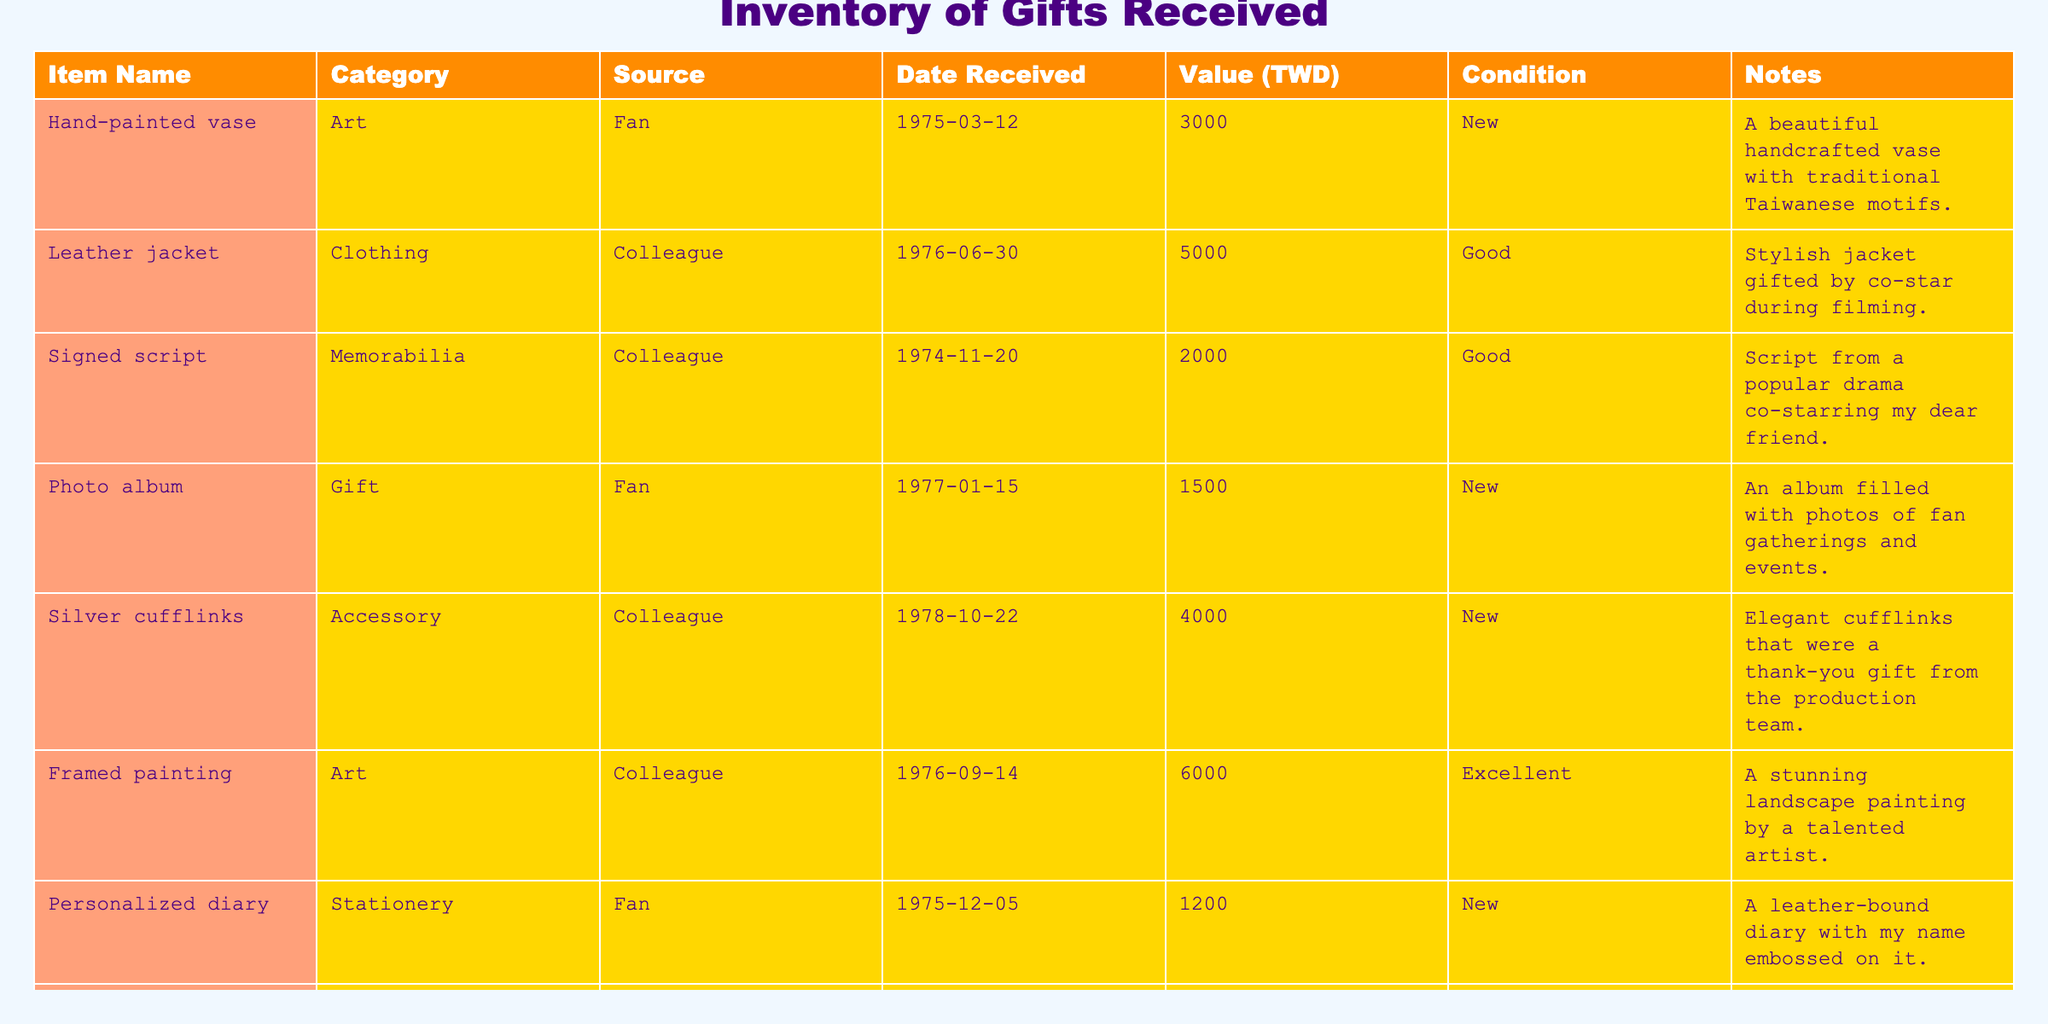What is the value of the hand-painted vase? The table shows that the value of the hand-painted vase is listed as 3000 TWD.
Answer: 3000 TWD How many gifts were received from fans? By reviewing the table, there are three items (hand-painted vase, photo album, ceramic tea set) listed under the source "Fan," indicating a total of three gifts from fans.
Answer: 3 Which item has the highest value? Comparing the values of all items in the table, the framed painting has the highest value at 6000 TWD.
Answer: 6000 TWD Is the personalized diary in new condition? The entry for the personalized diary states that its condition is "New," confirming that the diary is indeed in new condition.
Answer: Yes What is the total value of gifts received from colleagues? The gifts from colleagues (leather jacket, signed script, silver cufflinks, framed painting, golden bell replica) have the following values: 5000 TWD + 2000 TWD + 4000 TWD + 6000 TWD + 3500 TWD = 20500 TWD. Thus, the total value of gifts from colleagues is 20500 TWD.
Answer: 20500 TWD Are there any gifts received that are categorized as "Kitchenware"? Looking at the table, there is one item categorized as "Kitchenware," which is the ceramic tea set. Therefore, the answer to this question is yes.
Answer: Yes What is the average value of all the gifts received? The total value of all gifts is 3000 + 5000 + 2000 + 1500 + 4000 + 6000 + 1200 + 3500 + 2500 = 24500 TWD. There are 9 items, so the average value is 24500/9 ≈ 2722.22 TWD.
Answer: 2722.22 TWD Which source gave the most gifts? Analyzing the source column, we find three gifts listed from "Fan" and five gifts from "Colleague," meaning the source "Colleague" gave the most gifts.
Answer: Colleague How many items are in excellent condition? In the table, only the framed painting is categorized as being in "Excellent" condition. Therefore, there is one item in excellent condition.
Answer: 1 